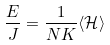<formula> <loc_0><loc_0><loc_500><loc_500>\frac { E } { J } = \frac { 1 } { N K } \langle { \mathcal { H } } \rangle</formula> 